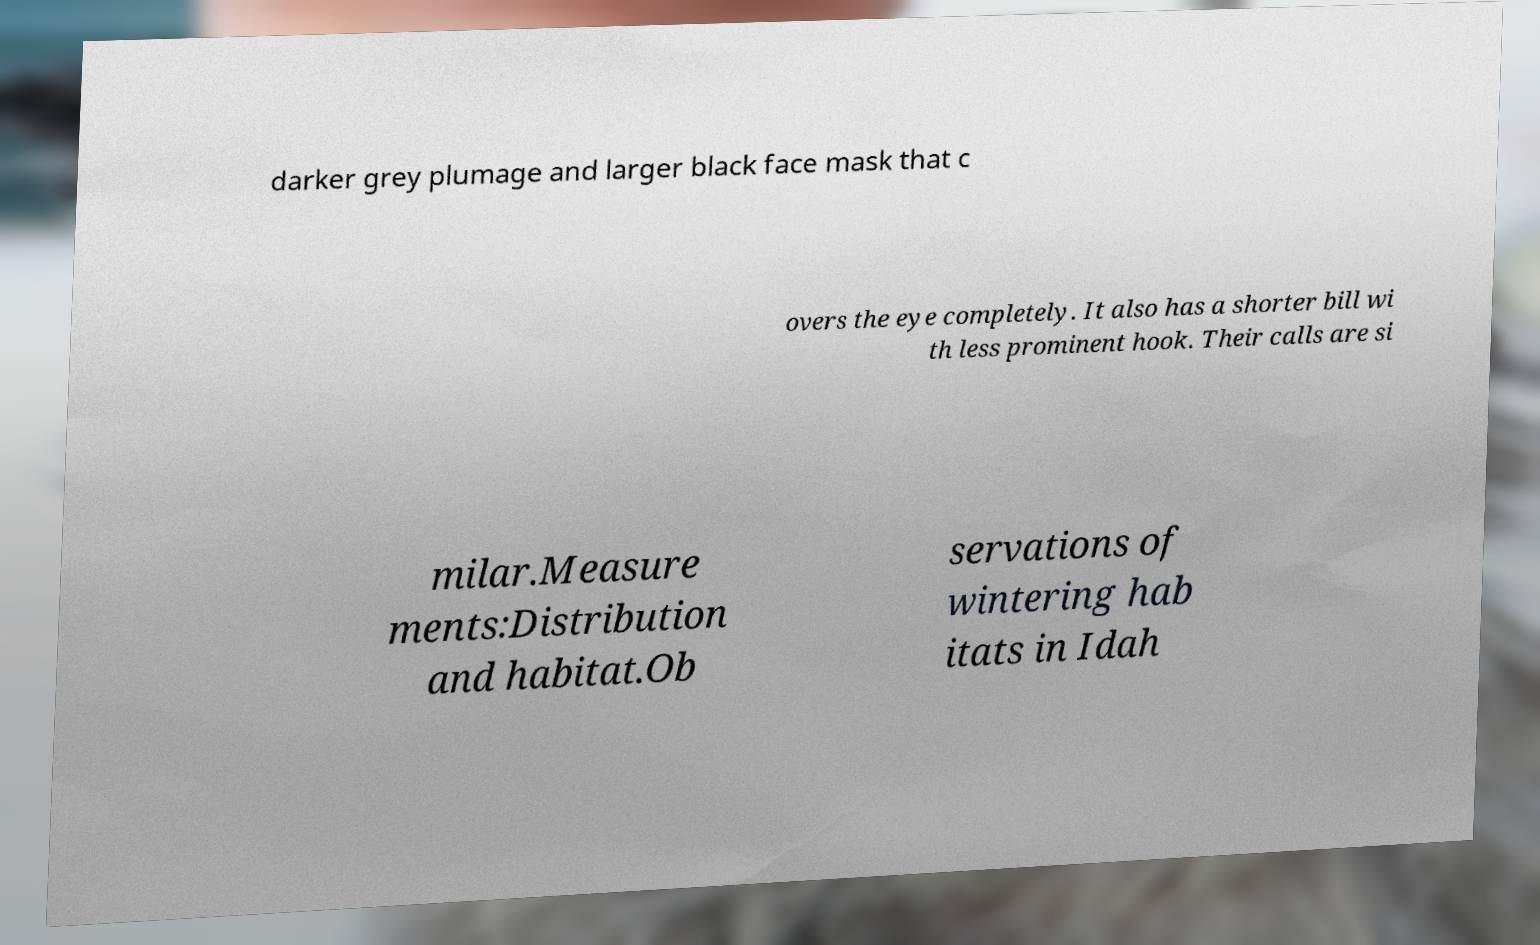Please read and relay the text visible in this image. What does it say? darker grey plumage and larger black face mask that c overs the eye completely. It also has a shorter bill wi th less prominent hook. Their calls are si milar.Measure ments:Distribution and habitat.Ob servations of wintering hab itats in Idah 